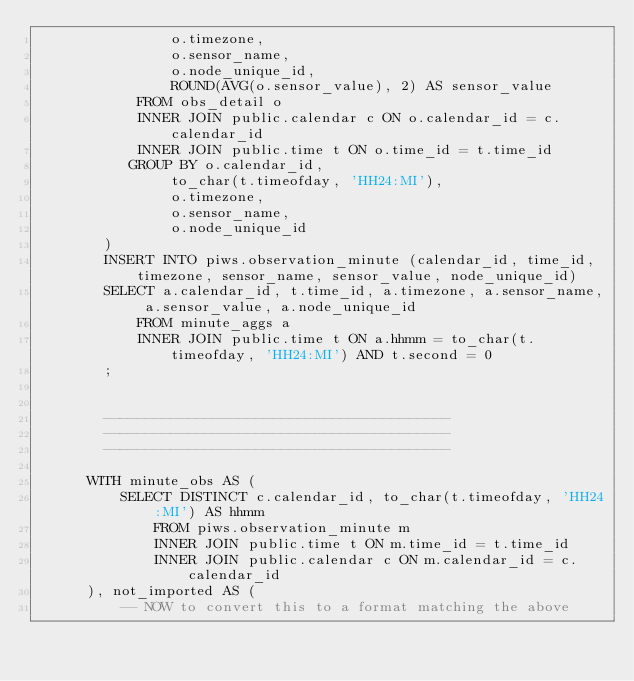Convert code to text. <code><loc_0><loc_0><loc_500><loc_500><_SQL_>                o.timezone,
                o.sensor_name,
                o.node_unique_id,
                ROUND(AVG(o.sensor_value), 2) AS sensor_value
            FROM obs_detail o
            INNER JOIN public.calendar c ON o.calendar_id = c.calendar_id
            INNER JOIN public.time t ON o.time_id = t.time_id
           GROUP BY o.calendar_id,
                to_char(t.timeofday, 'HH24:MI'),
                o.timezone,
                o.sensor_name,
                o.node_unique_id
        )
        INSERT INTO piws.observation_minute (calendar_id, time_id, timezone, sensor_name, sensor_value, node_unique_id)
        SELECT a.calendar_id, t.time_id, a.timezone, a.sensor_name, a.sensor_value, a.node_unique_id
            FROM minute_aggs a
            INNER JOIN public.time t ON a.hhmm = to_char(t.timeofday, 'HH24:MI') AND t.second = 0
        ;


        -----------------------------------------
        -----------------------------------------
        -----------------------------------------

	    WITH minute_obs AS (
	        SELECT DISTINCT c.calendar_id, to_char(t.timeofday, 'HH24:MI') AS hhmm
	            FROM piws.observation_minute m
	            INNER JOIN public.time t ON m.time_id = t.time_id
	            INNER JOIN public.calendar c ON m.calendar_id = c.calendar_id
	    ), not_imported AS (
	        -- NOW to convert this to a format matching the above</code> 